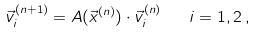<formula> <loc_0><loc_0><loc_500><loc_500>\vec { v } _ { i } ^ { ( n + 1 ) } = A ( \vec { x } ^ { ( n ) } ) \cdot \vec { v } _ { i } ^ { ( n ) } \quad i = 1 , 2 \, ,</formula> 